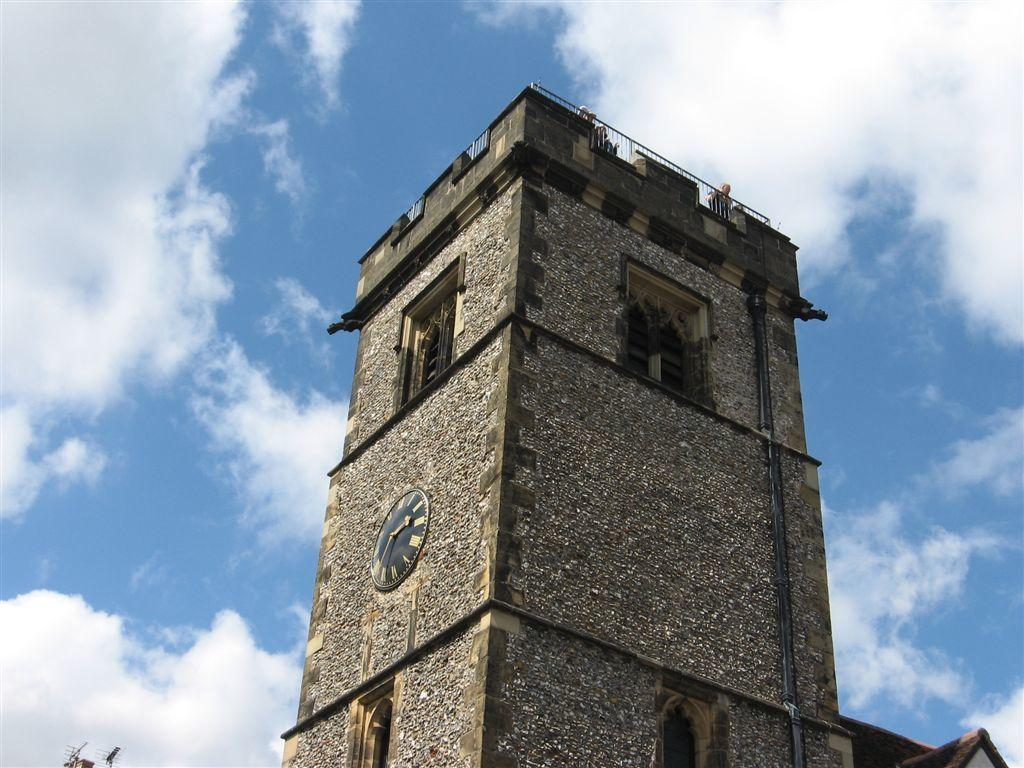What is the main subject of the picture? The main subject of the picture is a clock tower. What specific features can be seen on the clock tower? The clock tower has windows. What can be seen in the background of the picture? The sky is visible in the background of the picture. How many kittens are playing in harmony on the clock tower in the image? There are no kittens present in the image, and they are not playing in harmony on the clock tower. 